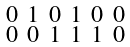Convert formula to latex. <formula><loc_0><loc_0><loc_500><loc_500>\begin{smallmatrix} 0 & 1 & 0 & 1 & 0 & 0 \\ 0 & 0 & 1 & 1 & 1 & 0 \\ \end{smallmatrix}</formula> 